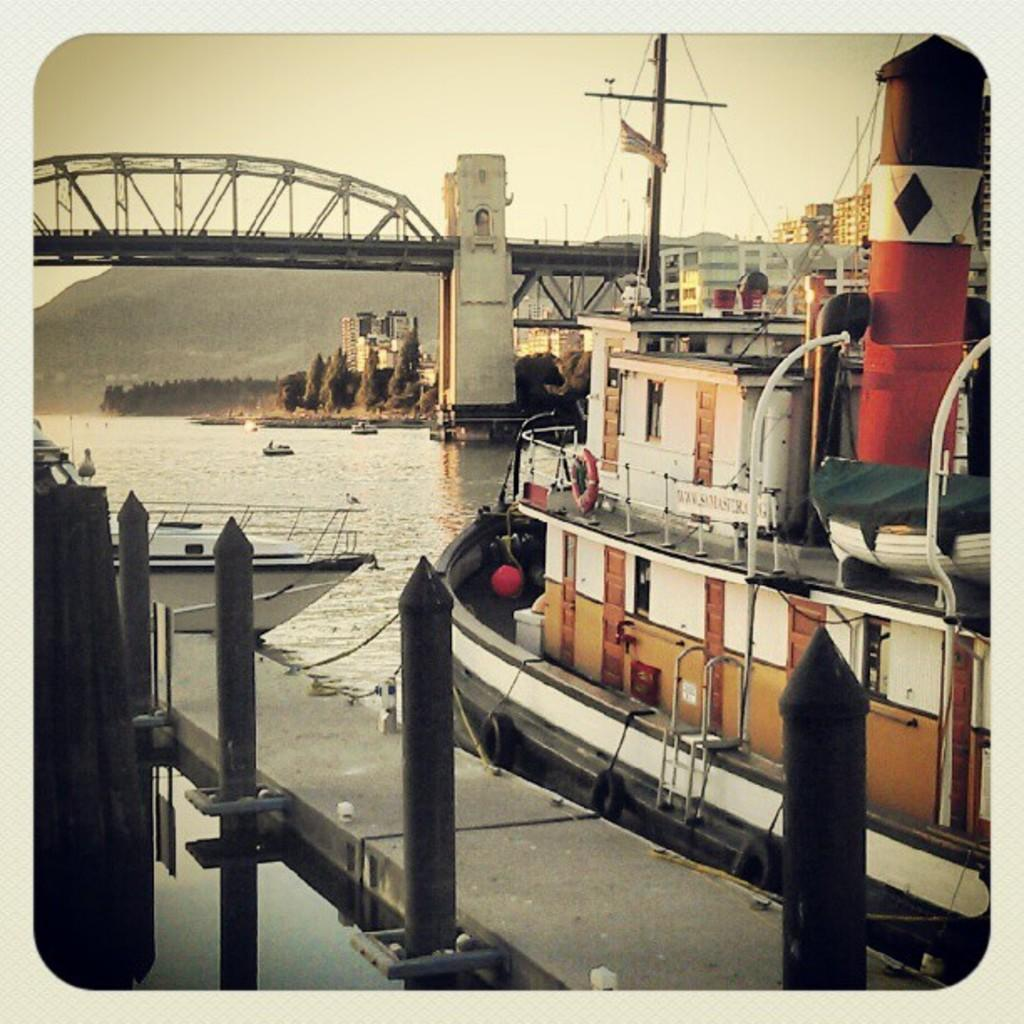What type of vehicles can be seen on the water in the image? There are boats on the water in the image. What structures are visible in the image? There are buildings and a bridge in the image. What type of vegetation is present in the image? There are trees in the image. What is attached to the flag in the image? There is a flag with a pole in the image. What type of landscape feature can be seen in the image? There are hills in the image. What part of the natural environment is visible in the background of the image? The sky is visible in the background of the image. How many cacti can be seen in the image? There are no cacti present in the image. What type of ticket is required to ride the boats in the image? There is no indication of any tickets or boat rides in the image. 